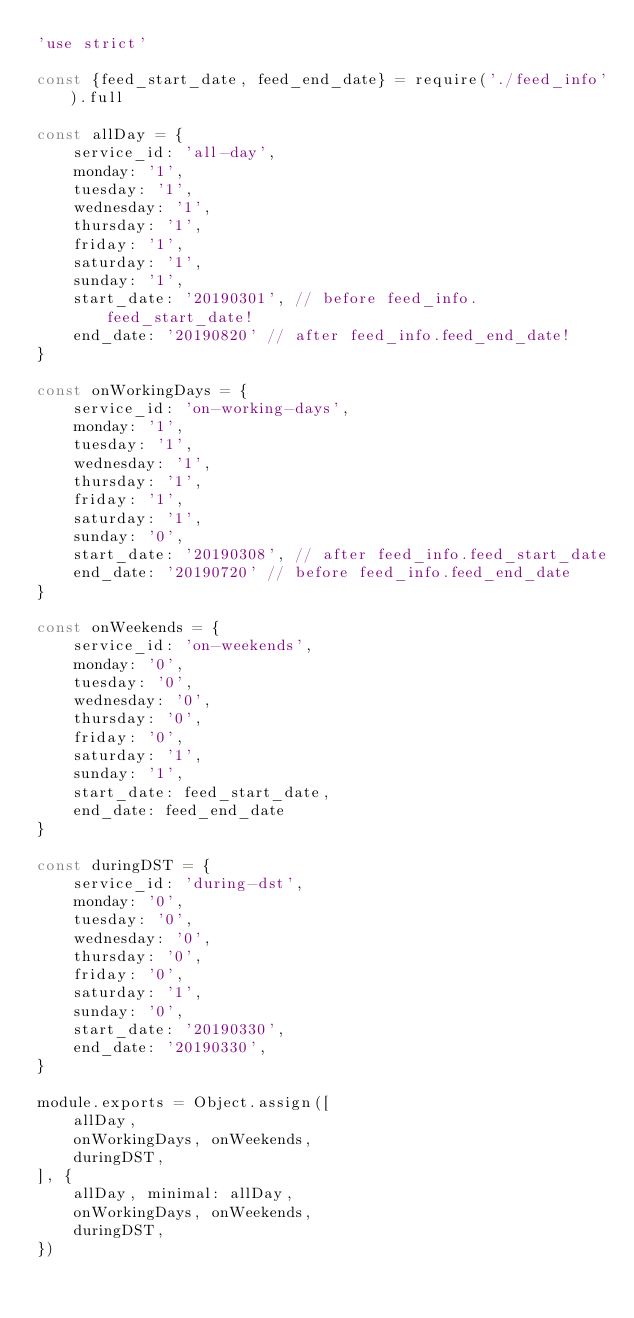<code> <loc_0><loc_0><loc_500><loc_500><_JavaScript_>'use strict'

const {feed_start_date, feed_end_date} = require('./feed_info').full

const allDay = {
	service_id: 'all-day',
	monday: '1',
	tuesday: '1',
	wednesday: '1',
	thursday: '1',
	friday: '1',
	saturday: '1',
	sunday: '1',
	start_date: '20190301', // before feed_info.feed_start_date!
	end_date: '20190820' // after feed_info.feed_end_date!
}

const onWorkingDays = {
	service_id: 'on-working-days',
	monday: '1',
	tuesday: '1',
	wednesday: '1',
	thursday: '1',
	friday: '1',
	saturday: '1',
	sunday: '0',
	start_date: '20190308', // after feed_info.feed_start_date
	end_date: '20190720' // before feed_info.feed_end_date
}

const onWeekends = {
	service_id: 'on-weekends',
	monday: '0',
	tuesday: '0',
	wednesday: '0',
	thursday: '0',
	friday: '0',
	saturday: '1',
	sunday: '1',
	start_date: feed_start_date,
	end_date: feed_end_date
}

const duringDST = {
	service_id: 'during-dst',
	monday: '0',
	tuesday: '0',
	wednesday: '0',
	thursday: '0',
	friday: '0',
	saturday: '1',
	sunday: '0',
	start_date: '20190330',
	end_date: '20190330',
}

module.exports = Object.assign([
	allDay,
	onWorkingDays, onWeekends,
	duringDST,
], {
	allDay, minimal: allDay,
	onWorkingDays, onWeekends,
	duringDST,
})
</code> 